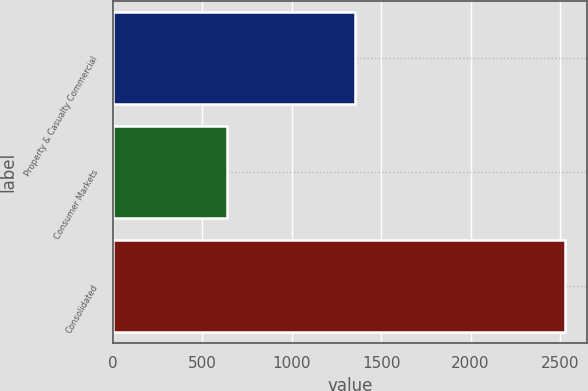<chart> <loc_0><loc_0><loc_500><loc_500><bar_chart><fcel>Property & Casualty Commercial<fcel>Consumer Markets<fcel>Consolidated<nl><fcel>1356<fcel>639<fcel>2527<nl></chart> 